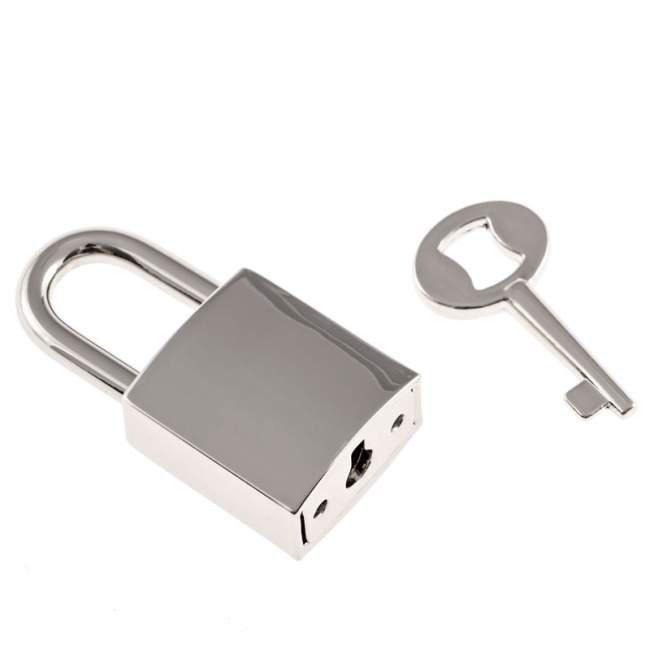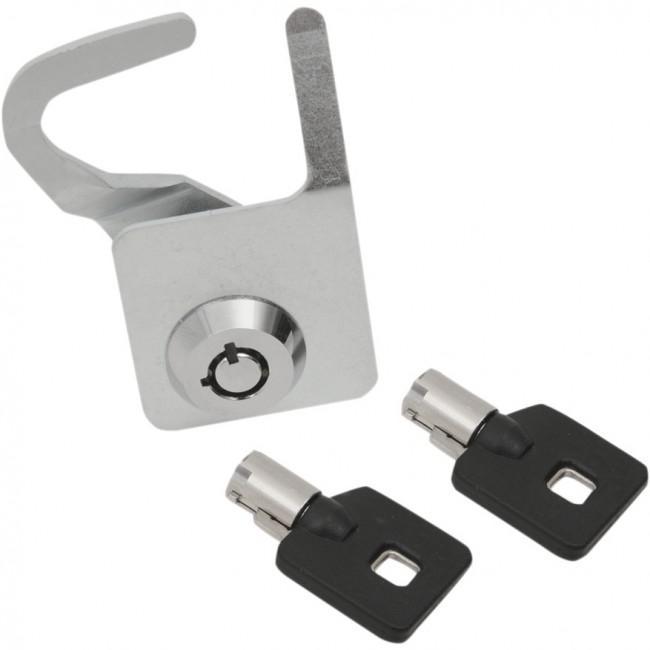The first image is the image on the left, the second image is the image on the right. Given the left and right images, does the statement "The left image shows a lock with a key on a keychain inserted." hold true? Answer yes or no. No. 